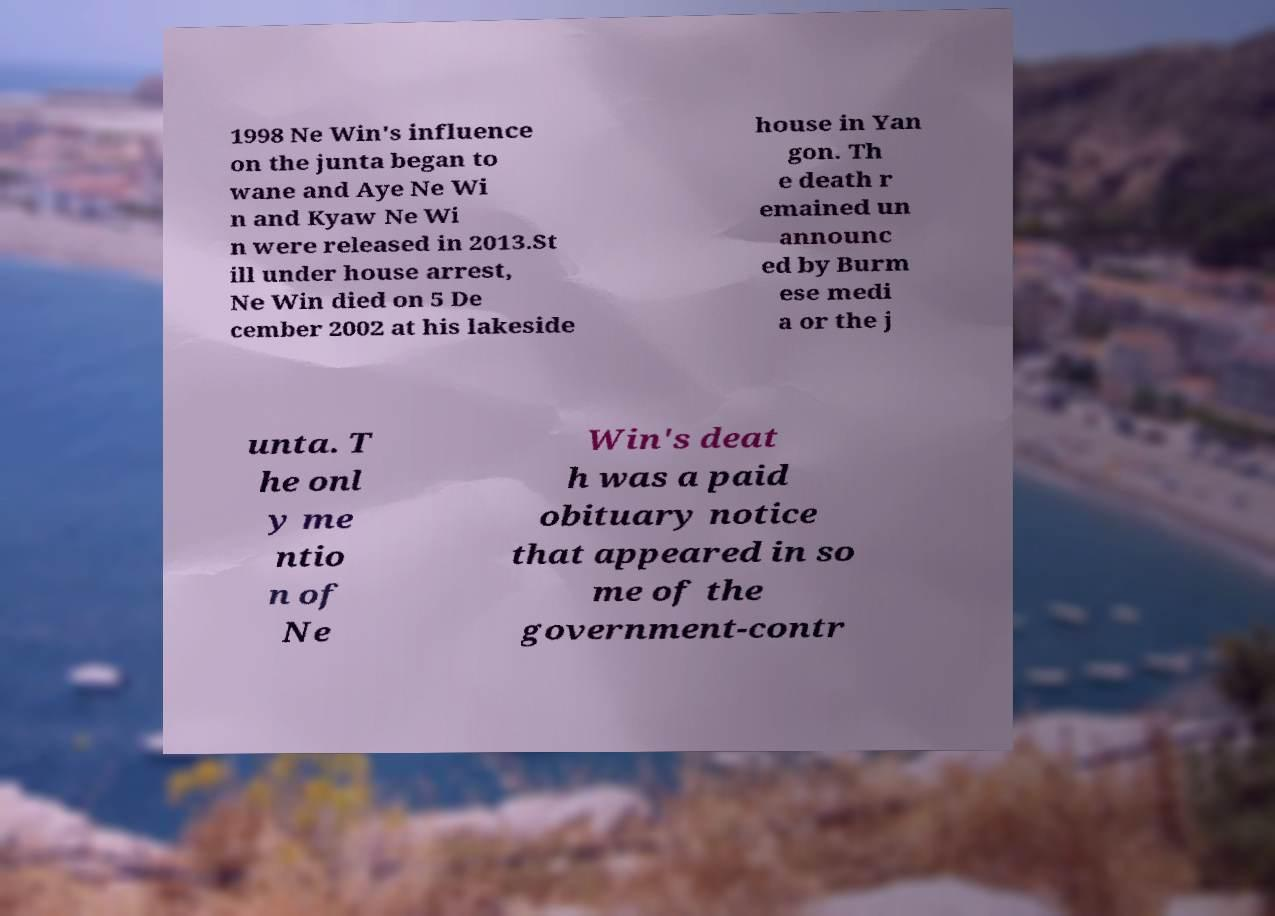I need the written content from this picture converted into text. Can you do that? 1998 Ne Win's influence on the junta began to wane and Aye Ne Wi n and Kyaw Ne Wi n were released in 2013.St ill under house arrest, Ne Win died on 5 De cember 2002 at his lakeside house in Yan gon. Th e death r emained un announc ed by Burm ese medi a or the j unta. T he onl y me ntio n of Ne Win's deat h was a paid obituary notice that appeared in so me of the government-contr 